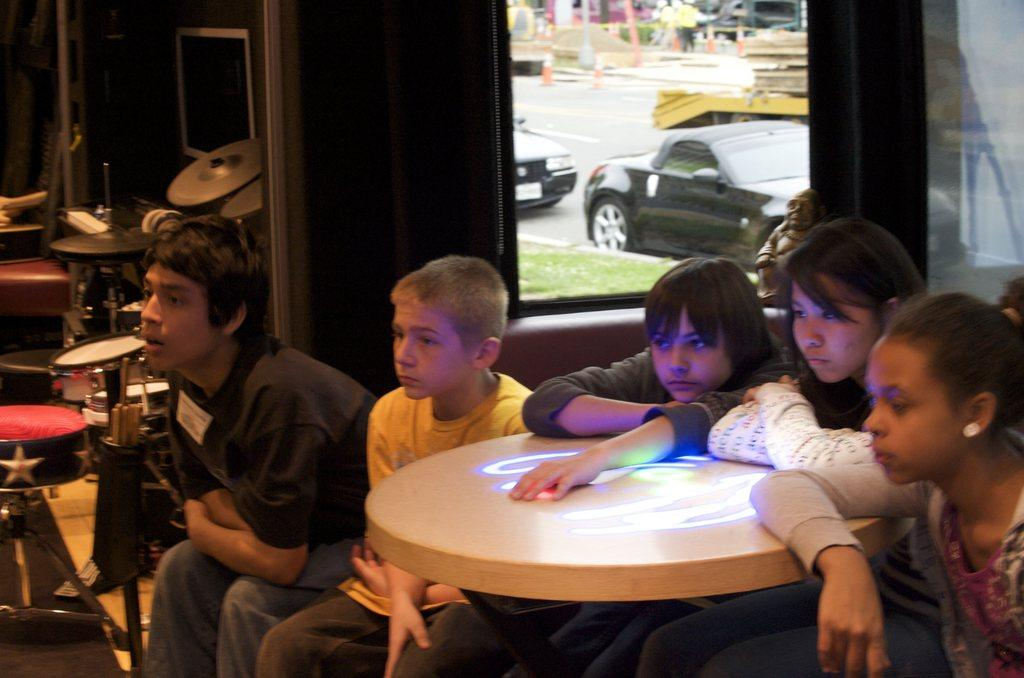What are the kids doing in the image? The kids are sitting on the table. What can be seen in the background of the image? There are many musical instruments and a window in the background. What is visible through the window? A car is visible through the window. What type of cake is being served to the pigs in the image? There is no cake or pigs present in the image. 